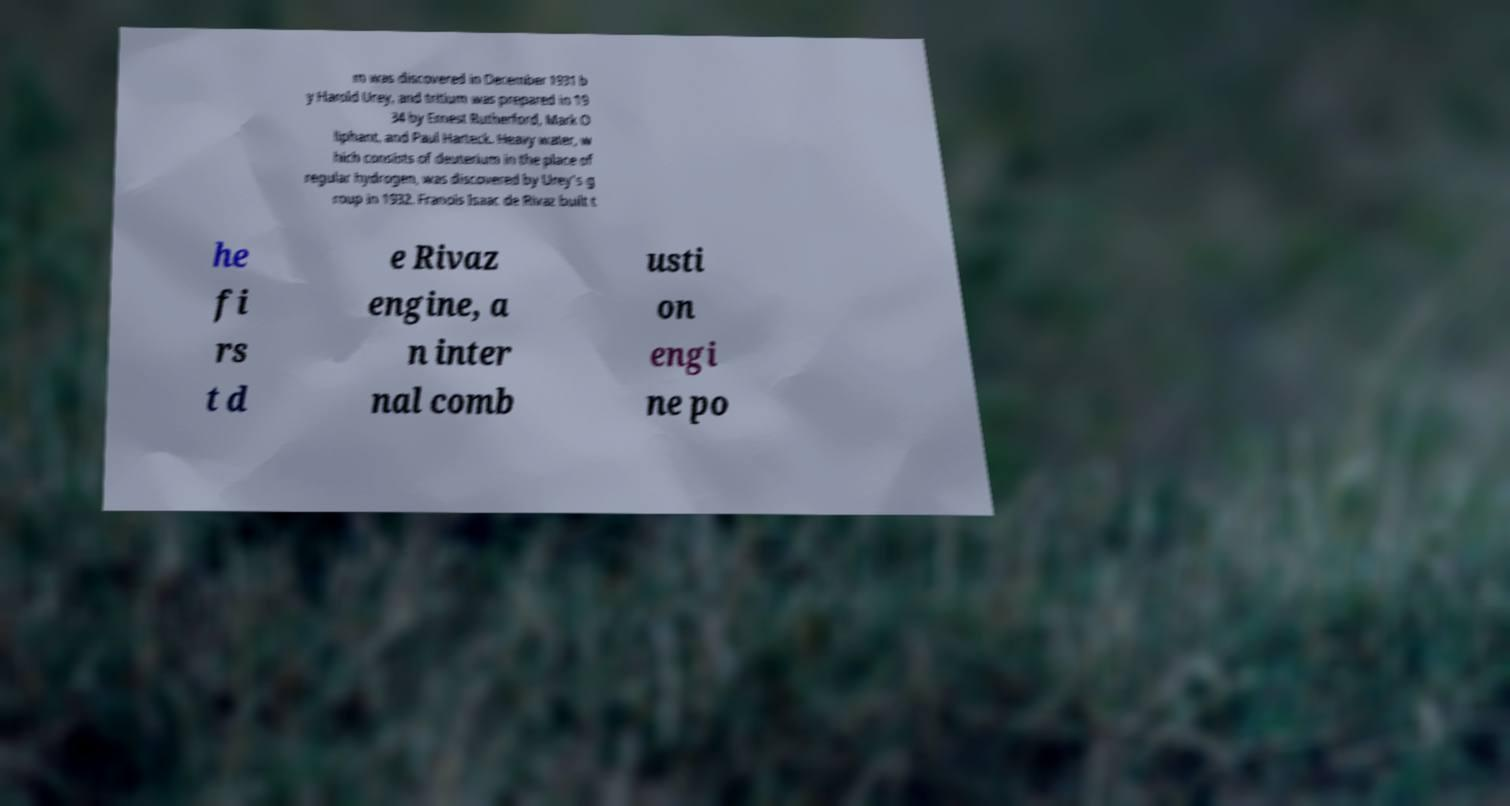Can you accurately transcribe the text from the provided image for me? m was discovered in December 1931 b y Harold Urey, and tritium was prepared in 19 34 by Ernest Rutherford, Mark O liphant, and Paul Harteck. Heavy water, w hich consists of deuterium in the place of regular hydrogen, was discovered by Urey's g roup in 1932. Franois Isaac de Rivaz built t he fi rs t d e Rivaz engine, a n inter nal comb usti on engi ne po 